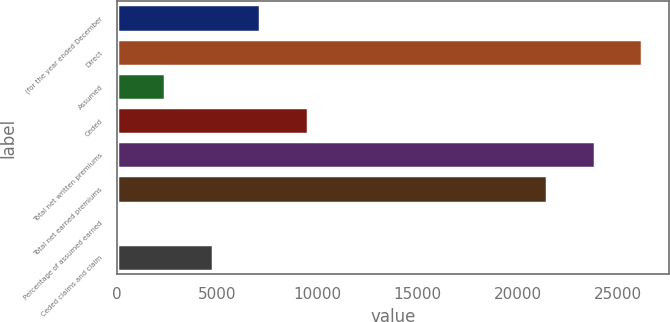Convert chart to OTSL. <chart><loc_0><loc_0><loc_500><loc_500><bar_chart><fcel>(for the year ended December<fcel>Direct<fcel>Assumed<fcel>Ceded<fcel>Total net written premiums<fcel>Total net earned premiums<fcel>Percentage of assumed earned<fcel>Ceded claims and claim<nl><fcel>7147.76<fcel>26234.6<fcel>2383.12<fcel>9530.08<fcel>23852.3<fcel>21470<fcel>0.8<fcel>4765.44<nl></chart> 